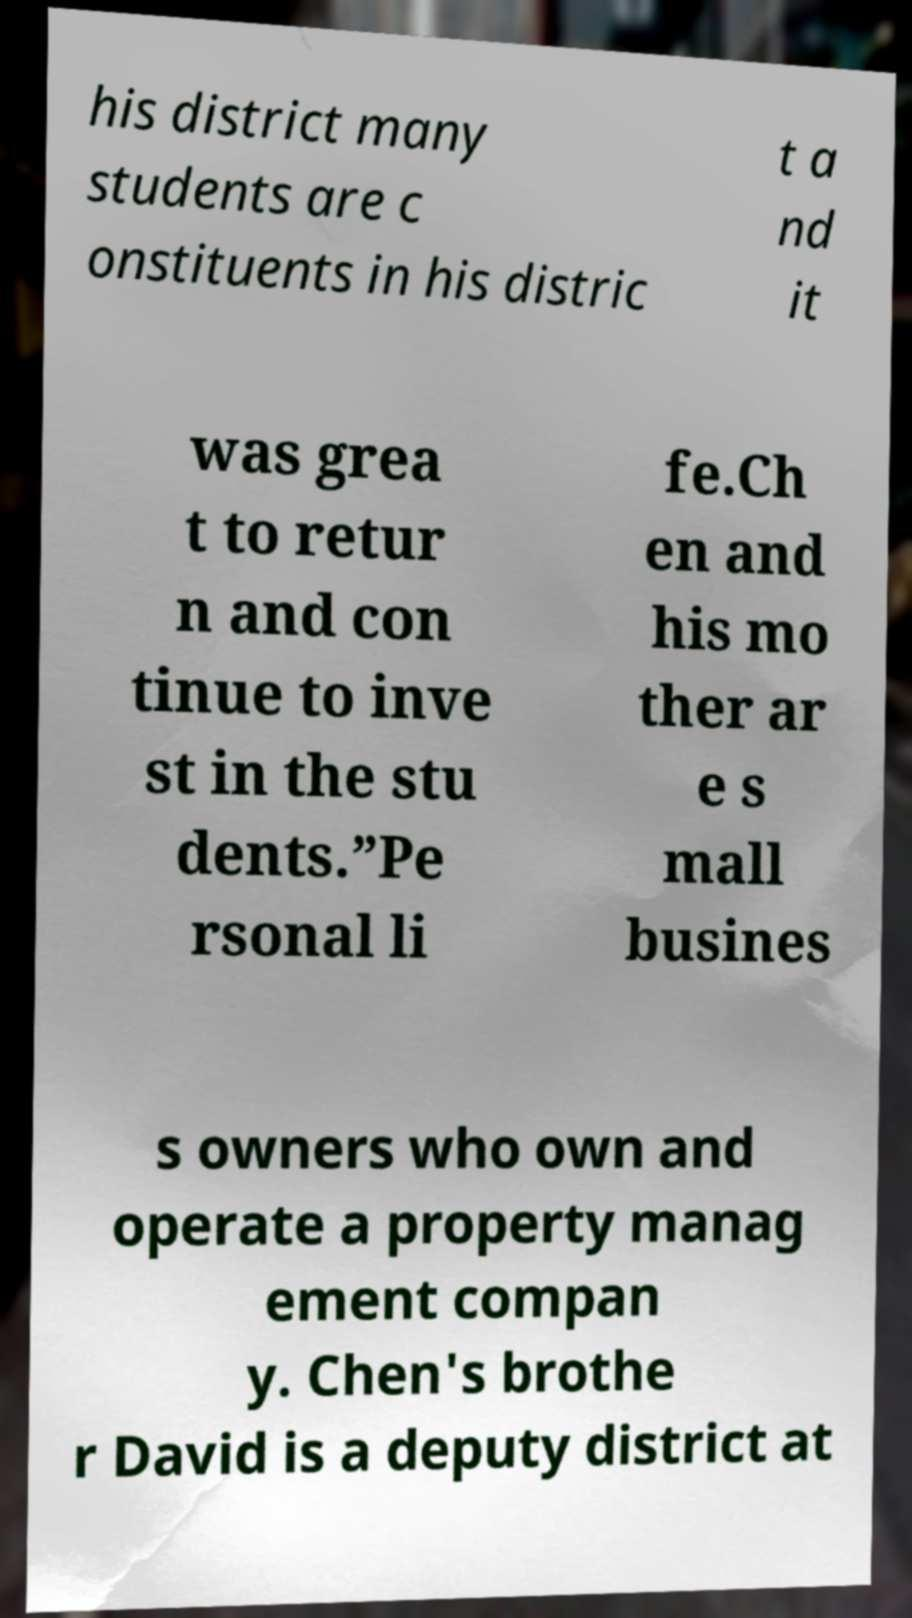For documentation purposes, I need the text within this image transcribed. Could you provide that? his district many students are c onstituents in his distric t a nd it was grea t to retur n and con tinue to inve st in the stu dents.”Pe rsonal li fe.Ch en and his mo ther ar e s mall busines s owners who own and operate a property manag ement compan y. Chen's brothe r David is a deputy district at 